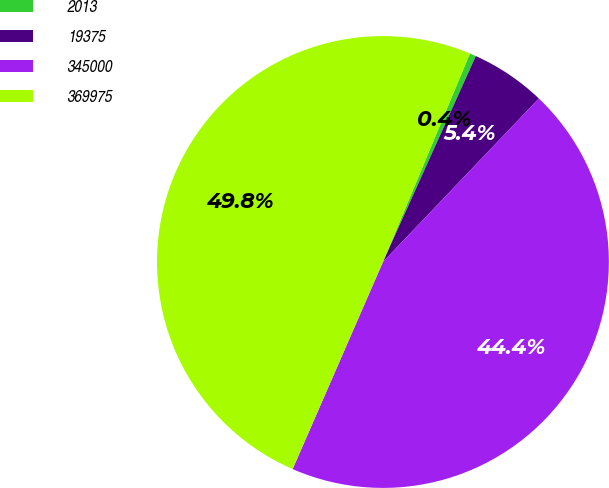Convert chart to OTSL. <chart><loc_0><loc_0><loc_500><loc_500><pie_chart><fcel>2013<fcel>19375<fcel>345000<fcel>369975<nl><fcel>0.45%<fcel>5.38%<fcel>44.42%<fcel>49.75%<nl></chart> 